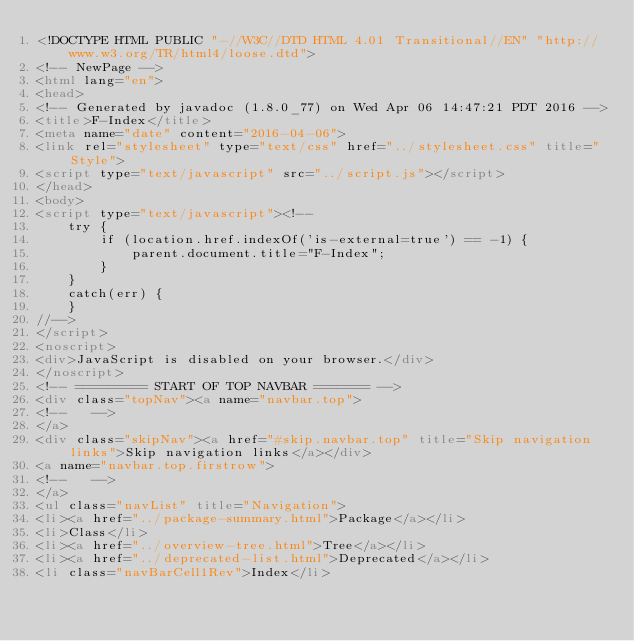<code> <loc_0><loc_0><loc_500><loc_500><_HTML_><!DOCTYPE HTML PUBLIC "-//W3C//DTD HTML 4.01 Transitional//EN" "http://www.w3.org/TR/html4/loose.dtd">
<!-- NewPage -->
<html lang="en">
<head>
<!-- Generated by javadoc (1.8.0_77) on Wed Apr 06 14:47:21 PDT 2016 -->
<title>F-Index</title>
<meta name="date" content="2016-04-06">
<link rel="stylesheet" type="text/css" href="../stylesheet.css" title="Style">
<script type="text/javascript" src="../script.js"></script>
</head>
<body>
<script type="text/javascript"><!--
    try {
        if (location.href.indexOf('is-external=true') == -1) {
            parent.document.title="F-Index";
        }
    }
    catch(err) {
    }
//-->
</script>
<noscript>
<div>JavaScript is disabled on your browser.</div>
</noscript>
<!-- ========= START OF TOP NAVBAR ======= -->
<div class="topNav"><a name="navbar.top">
<!--   -->
</a>
<div class="skipNav"><a href="#skip.navbar.top" title="Skip navigation links">Skip navigation links</a></div>
<a name="navbar.top.firstrow">
<!--   -->
</a>
<ul class="navList" title="Navigation">
<li><a href="../package-summary.html">Package</a></li>
<li>Class</li>
<li><a href="../overview-tree.html">Tree</a></li>
<li><a href="../deprecated-list.html">Deprecated</a></li>
<li class="navBarCell1Rev">Index</li></code> 